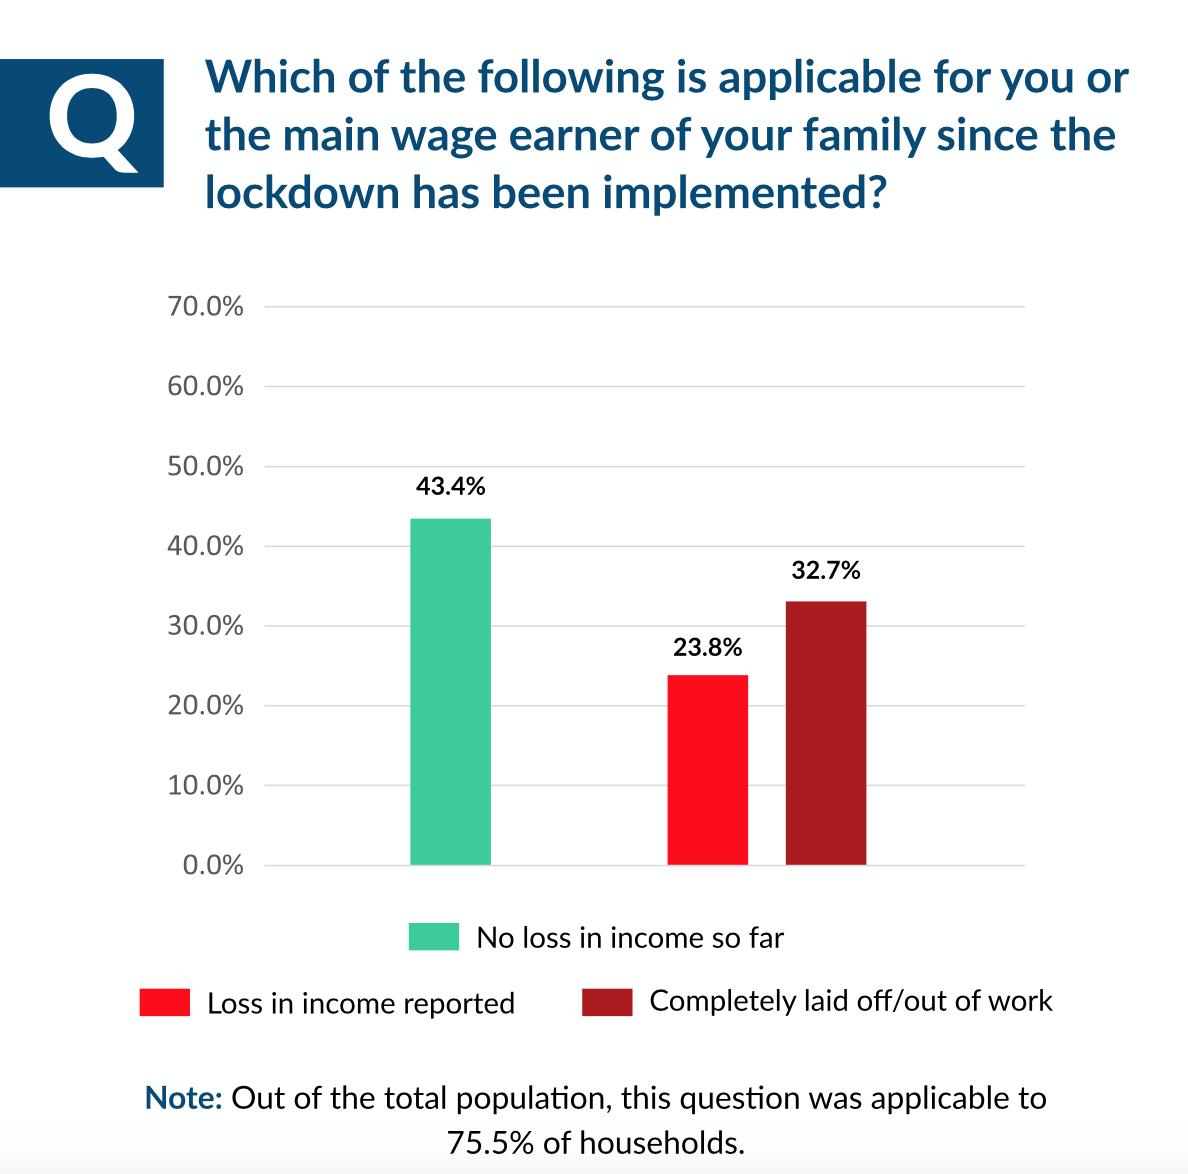Mention a couple of crucial points in this snapshot. A total of 32.7% of respondents reported that they are currently unemployed since the lockdown has been enforced. A total of 23.8% of respondents reported a loss in income since the lockdown has been implemented. According to the survey, 43.4% of respondents reported no loss of income since the lockdown was implemented. 